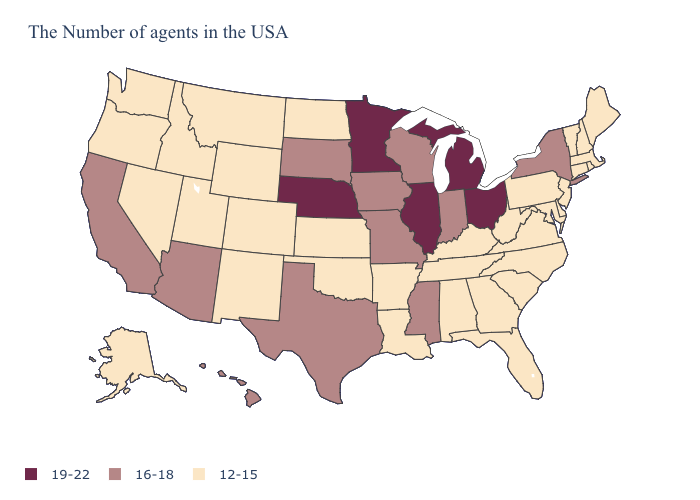Does the first symbol in the legend represent the smallest category?
Answer briefly. No. Which states have the highest value in the USA?
Quick response, please. Ohio, Michigan, Illinois, Minnesota, Nebraska. Does Maine have a lower value than Colorado?
Give a very brief answer. No. How many symbols are there in the legend?
Concise answer only. 3. Name the states that have a value in the range 12-15?
Keep it brief. Maine, Massachusetts, Rhode Island, New Hampshire, Vermont, Connecticut, New Jersey, Delaware, Maryland, Pennsylvania, Virginia, North Carolina, South Carolina, West Virginia, Florida, Georgia, Kentucky, Alabama, Tennessee, Louisiana, Arkansas, Kansas, Oklahoma, North Dakota, Wyoming, Colorado, New Mexico, Utah, Montana, Idaho, Nevada, Washington, Oregon, Alaska. Name the states that have a value in the range 16-18?
Short answer required. New York, Indiana, Wisconsin, Mississippi, Missouri, Iowa, Texas, South Dakota, Arizona, California, Hawaii. What is the value of Delaware?
Quick response, please. 12-15. Does Colorado have a lower value than Ohio?
Quick response, please. Yes. What is the highest value in states that border Florida?
Short answer required. 12-15. Does New York have the highest value in the Northeast?
Keep it brief. Yes. Name the states that have a value in the range 12-15?
Answer briefly. Maine, Massachusetts, Rhode Island, New Hampshire, Vermont, Connecticut, New Jersey, Delaware, Maryland, Pennsylvania, Virginia, North Carolina, South Carolina, West Virginia, Florida, Georgia, Kentucky, Alabama, Tennessee, Louisiana, Arkansas, Kansas, Oklahoma, North Dakota, Wyoming, Colorado, New Mexico, Utah, Montana, Idaho, Nevada, Washington, Oregon, Alaska. What is the value of Michigan?
Answer briefly. 19-22. Name the states that have a value in the range 16-18?
Short answer required. New York, Indiana, Wisconsin, Mississippi, Missouri, Iowa, Texas, South Dakota, Arizona, California, Hawaii. What is the value of South Dakota?
Short answer required. 16-18. What is the highest value in the USA?
Concise answer only. 19-22. 